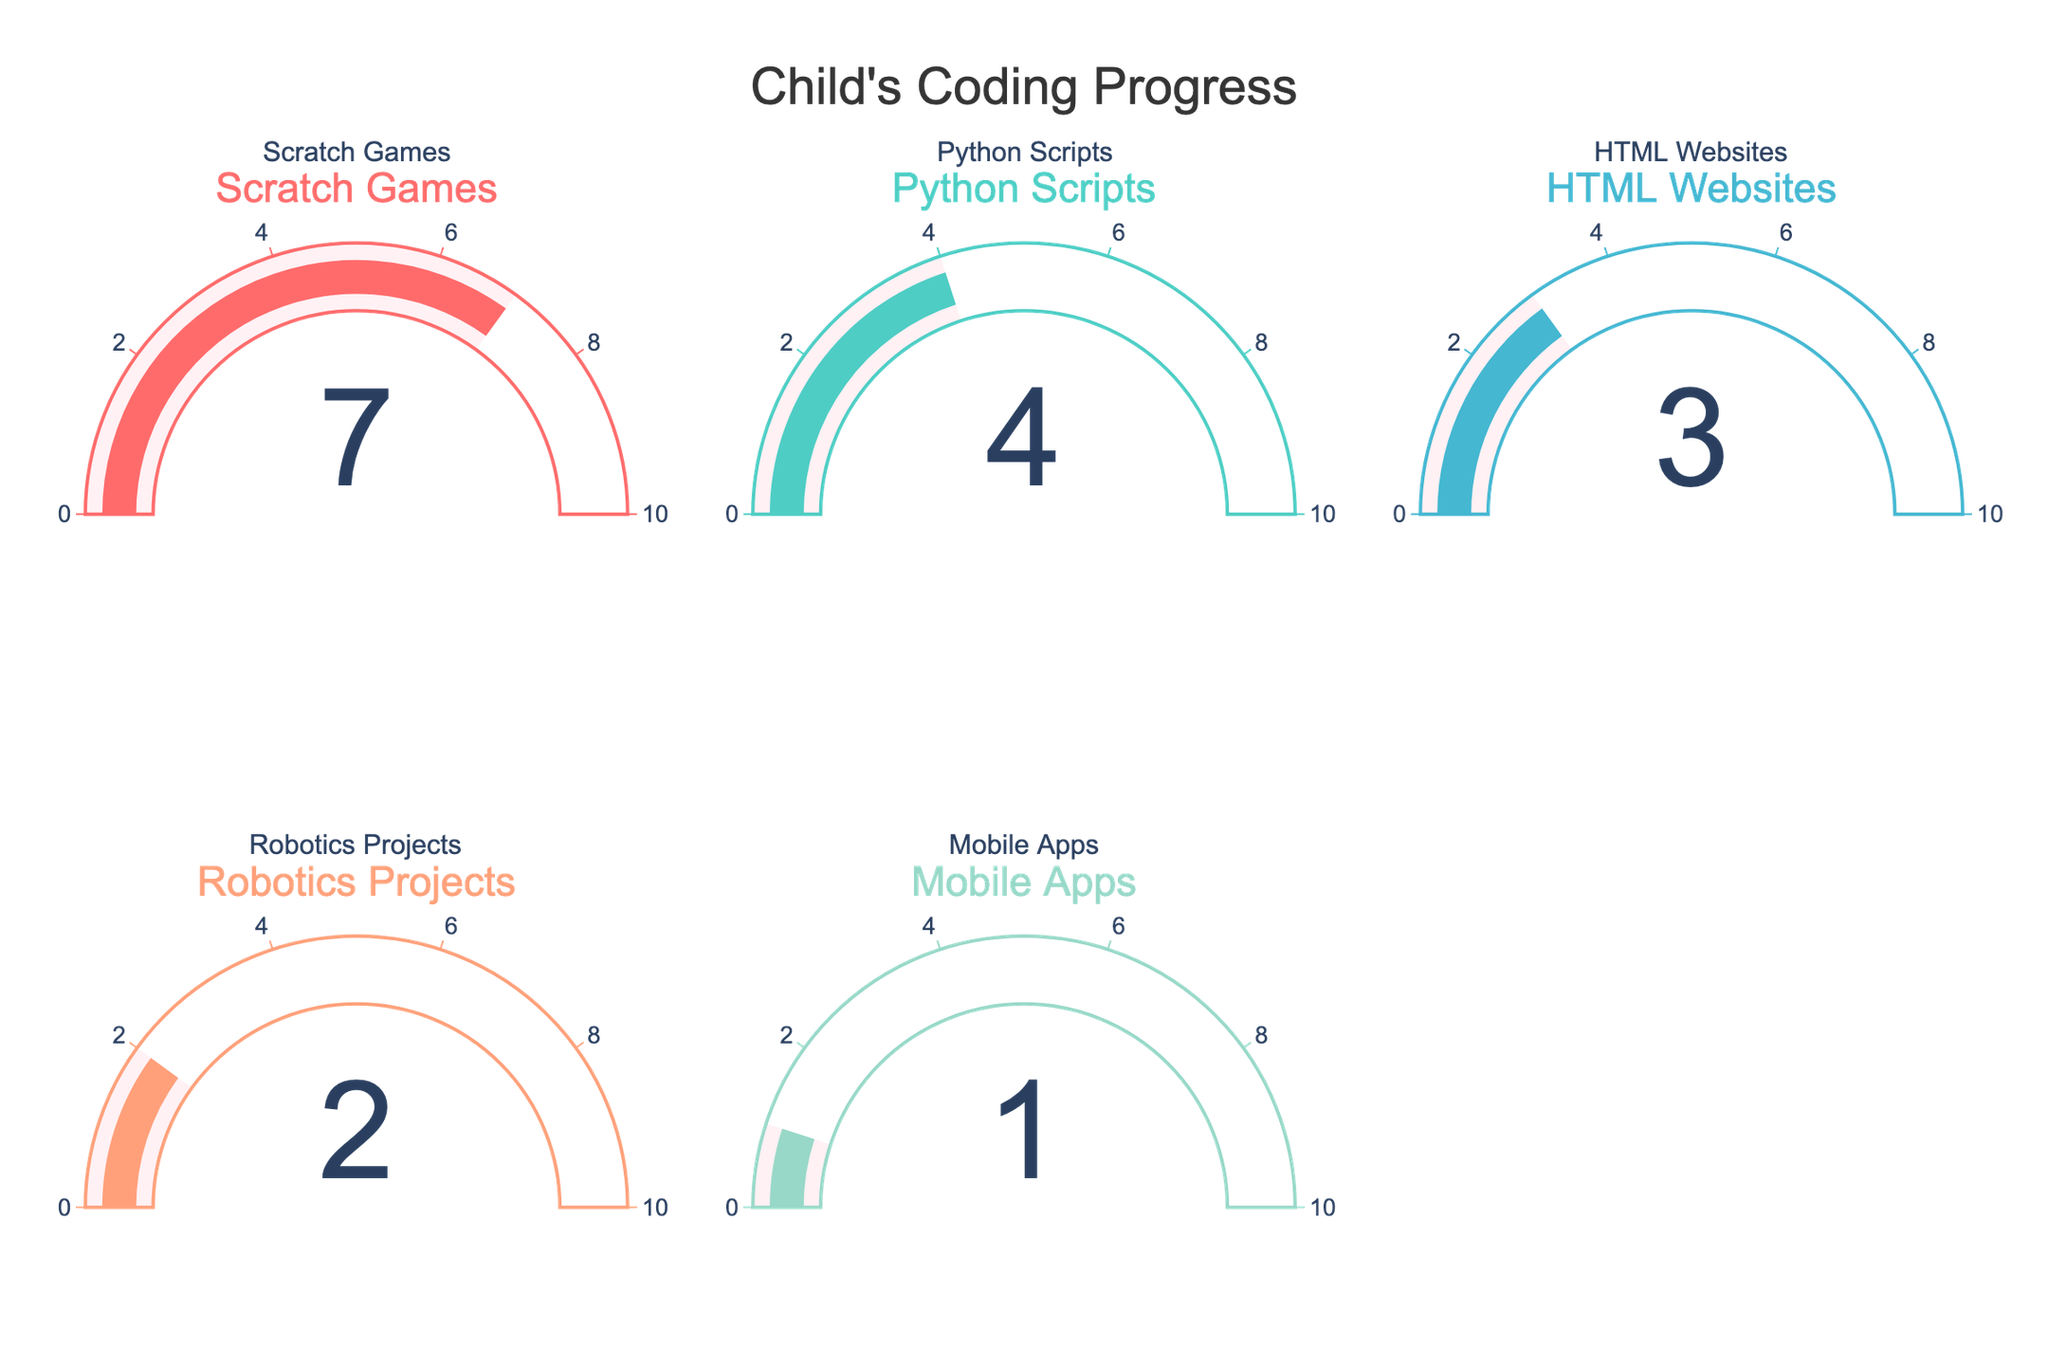Which project type has the highest number of completed projects? Look at the gauge chart that shows the number of completed projects for all types. The one with the highest number is the one with the longest gauge bar towards the maximum value.
Answer: Scratch Games How many more Python Scripts are completed compared to Mobile Apps? To find the difference, look at the values on the gauges for Python Scripts and Mobile Apps. Subtract the number of completed Mobile Apps from the number of completed Python Scripts.
Answer: 3 What's the total number of coding projects completed? To get the total, sum the number of completed projects for all project types displayed on the gauges: 7 (Scratch Games) + 4 (Python Scripts) + 3 (HTML Websites) + 2 (Robotics Projects) + 1 (Mobile Apps).
Answer: 17 Which project type has the least number of completed projects? Check each gauge and compare the values. The one with the smallest value represents the project type with the least completed projects.
Answer: Mobile Apps Combine the numbers for HTML Websites and Robotics Projects, what's the sum? Add the number of completed HTML Websites to the number of completed Robotics Projects: 3 (HTML Websites) + 2 (Robotics Projects).
Answer: 5 Are there more Scratch Games than Python Scripts and HTML Websites combined? First, find the combined number of Python Scripts and HTML Websites: 4 (Python Scripts) + 3 (HTML Websites) = 7. Compare this sum to the number of Scratch Games.
Answer: No What's the average number of completed projects across all categories? Add up all the completed projects and divide by the number of categories: (7 + 4 + 3 + 2 + 1) / 5.
Answer: 3.4 Which projects have been completed an equal number of times, if any? Check all gauges for matching numbers of completed projects.
Answer: None What is the range of completed projects between the highest and lowest project types? Subtract the lowest number of completed projects from the highest: 7 (highest, Scratch Games) - 1 (lowest, Mobile Apps).
Answer: 6 